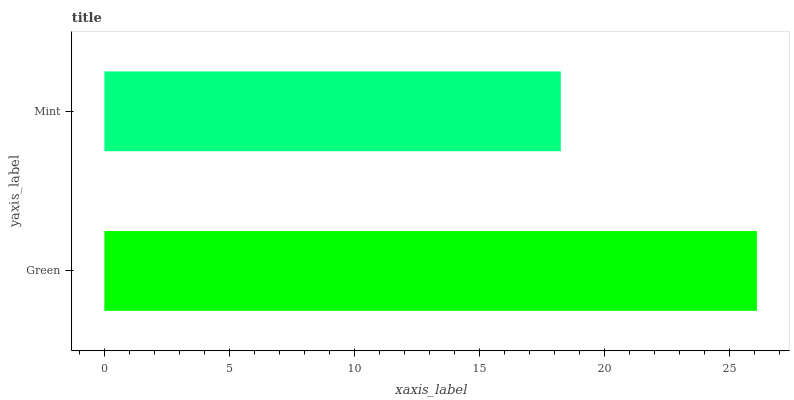Is Mint the minimum?
Answer yes or no. Yes. Is Green the maximum?
Answer yes or no. Yes. Is Mint the maximum?
Answer yes or no. No. Is Green greater than Mint?
Answer yes or no. Yes. Is Mint less than Green?
Answer yes or no. Yes. Is Mint greater than Green?
Answer yes or no. No. Is Green less than Mint?
Answer yes or no. No. Is Green the high median?
Answer yes or no. Yes. Is Mint the low median?
Answer yes or no. Yes. Is Mint the high median?
Answer yes or no. No. Is Green the low median?
Answer yes or no. No. 